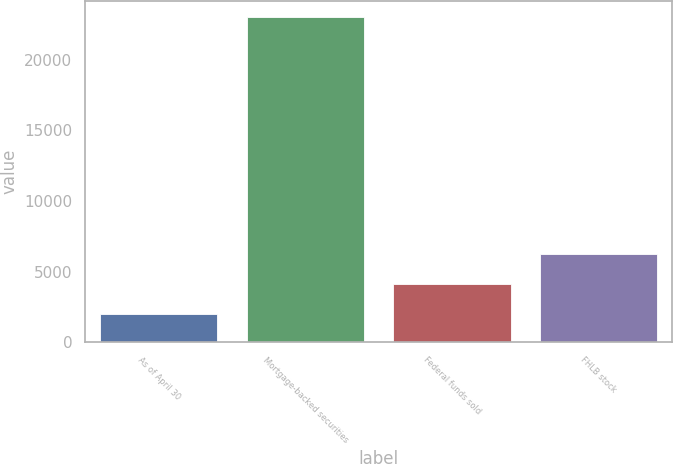Convert chart to OTSL. <chart><loc_0><loc_0><loc_500><loc_500><bar_chart><fcel>As of April 30<fcel>Mortgage-backed securities<fcel>Federal funds sold<fcel>FHLB stock<nl><fcel>2010<fcel>23026<fcel>4111.6<fcel>6213.2<nl></chart> 